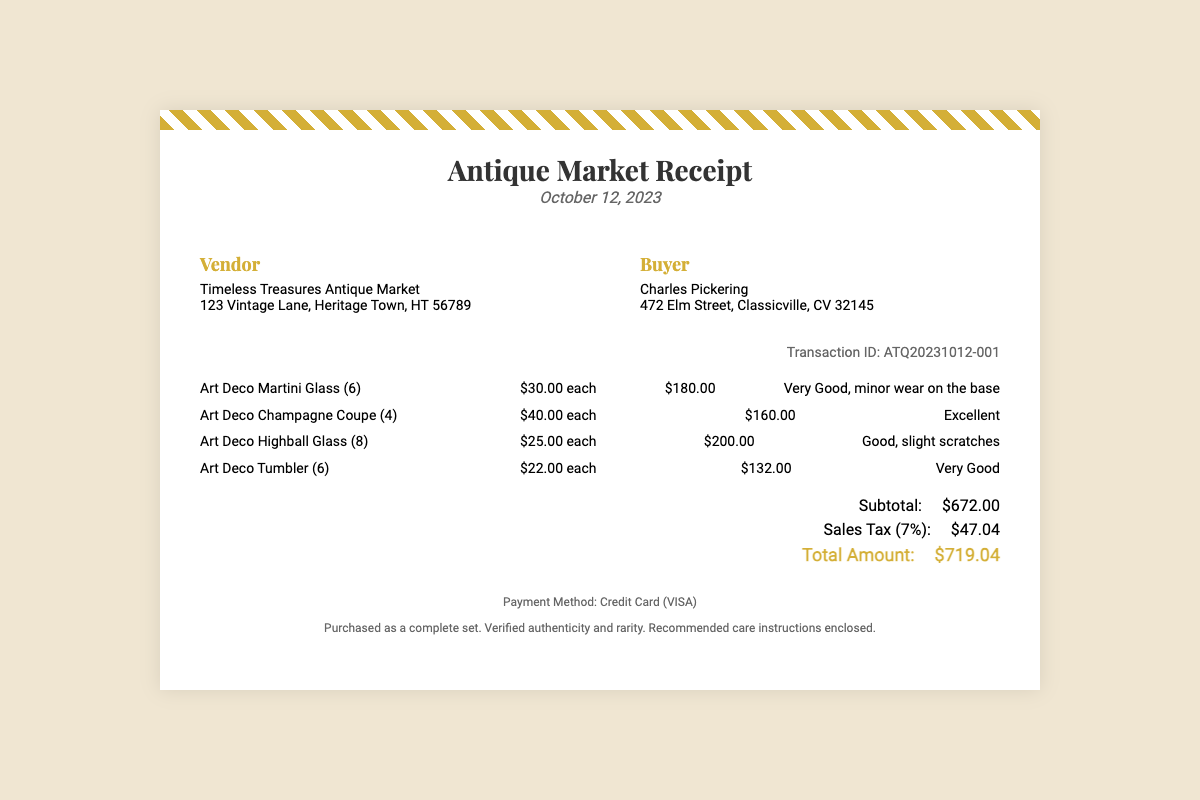What is the name of the vendor? The vendor's name is listed at the beginning of the document, which is "Timeless Treasures Antique Market."
Answer: Timeless Treasures Antique Market What is the purchase date? The date of purchase is shown in the header of the document, which is "October 12, 2023."
Answer: October 12, 2023 How many Art Deco Champagne Coupes were purchased? The receipt indicates that "Art Deco Champagne Coupe (4)" were purchased, showing the quantity directly.
Answer: 4 What is the condition of the Art Deco Highball Glasses? The condition of the Art Deco Highball Glasses is specified in the itemization, which states "Good, slight scratches."
Answer: Good, slight scratches What is the subtotal amount? The subtotal is clearly labeled in the totals section of the document, which lists the subtotal as "$672.00."
Answer: $672.00 What is the total amount after tax? The total amount is mentioned as the final figure in the totals section, labeled "Total Amount."
Answer: $719.04 What payment method was used? The payment method is mentioned in the footer of the document as "Credit Card (VISA)."
Answer: Credit Card (VISA) What is the transaction ID? The transaction ID is displayed in the document, specifically mentioned as "Transaction ID: ATQ20231012-001."
Answer: ATQ20231012-001 What was noted about the authenticity of the items? The footer mentions that the items are "verified authenticity and rarity."
Answer: verified authenticity and rarity 